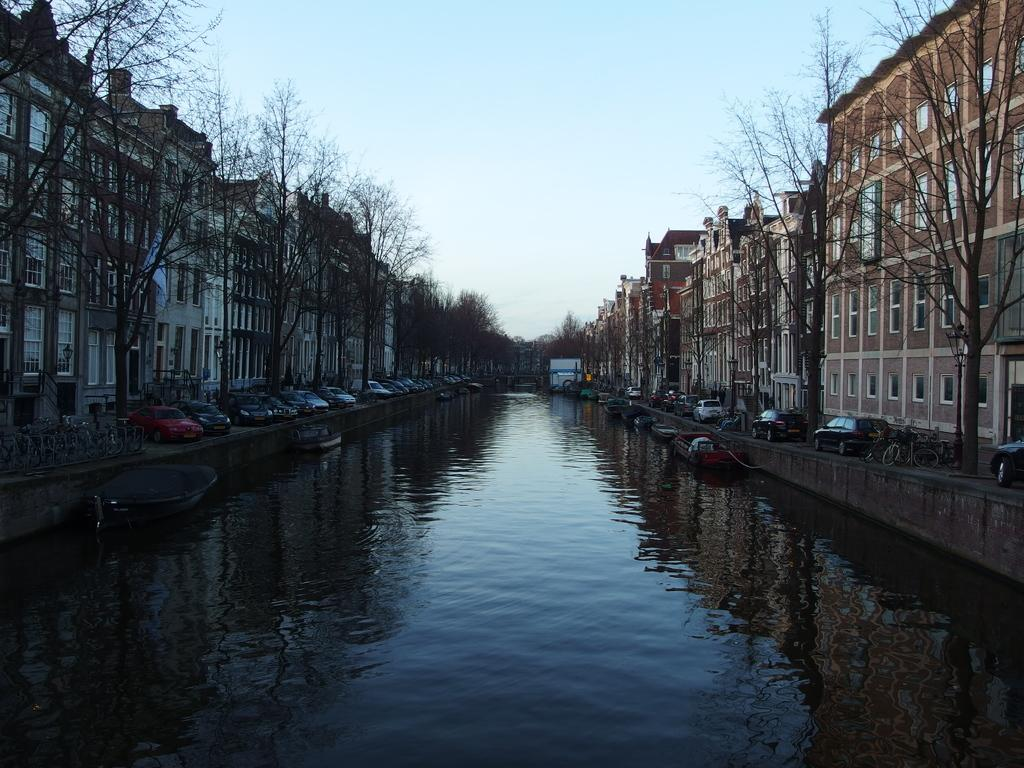What is the main subject of the image? The main subject of the image is water at the center. What is on the water in the image? There are boats on the water. What other types of transportation can be seen in the image? There are vehicles visible in the image. What type of natural environment is present in the image? Trees are present in the image. What type of man-made structures are visible in the image? There are buildings in the image. What is visible at the top of the image? The sky is visible at the top of the image. What language is spoken by the trees in the image? Trees do not speak any language, so this question cannot be answered. 